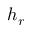<formula> <loc_0><loc_0><loc_500><loc_500>h _ { r }</formula> 